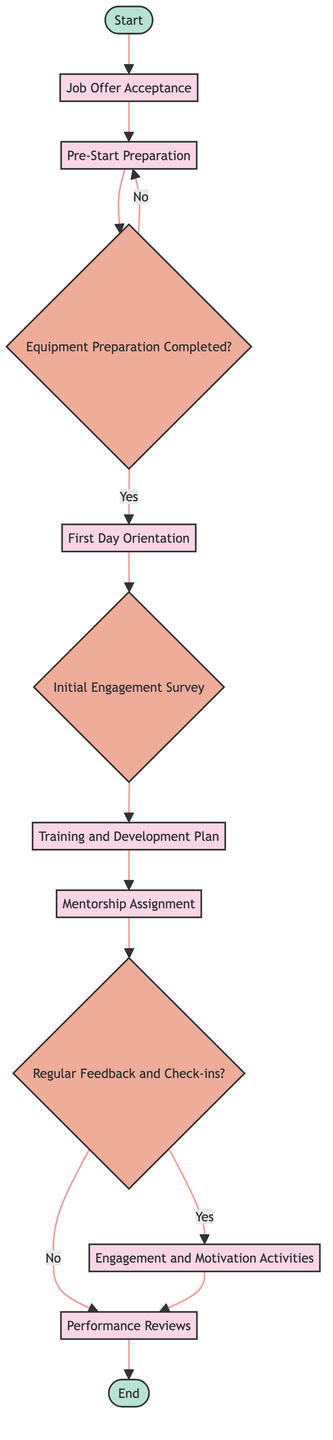What is the starting point of the onboarding process? The diagram begins at the "Start" node, indicating the entry point of the onboarding process.
Answer: Start How many decision nodes are there in the flowchart? The flowchart contains three decision nodes: "Equipment Preparation Completed?", "Initial Engagement Survey", and "Regular Feedback and Check-ins?".
Answer: 3 Which process comes after the "First Day Orientation"? Following the "First Day Orientation", the next action is to distribute the "Initial Engagement Survey".
Answer: Initial Engagement Survey What happens if "Equipment Preparation Completed?" is answered with "No"? If "Equipment Preparation Completed?" is answered with "No", the flowchart redirects back to "Pre-Start Preparation" for further action.
Answer: Pre-Start Preparation What is the end point of the onboarding process? The final point in the flowchart is the "End" node, which signifies the completion of the onboarding process.
Answer: End How many processes are in the onboarding flowchart? There are seven designated processes in the flowchart: "Job Offer Acceptance", "Pre-Start Preparation", "First Day Orientation", "Training and Development Plan", "Mentorship Assignment", "Engagement and Motivation Activities", and "Performance Reviews".
Answer: 7 What is the significance of the "Regular Feedback and Check-ins?" decision node? The "Regular Feedback and Check-ins?" node determines whether the onboarding process will include "Engagement and Motivation Activities" or go directly to "Performance Reviews", affecting the new hire's integration.
Answer: Engagement and Motivation Activities or Performance Reviews Which node follows the "Mentorship Assignment"? After "Mentorship Assignment," the next node in the process is "Regular Feedback and Check-ins?".
Answer: Regular Feedback and Check-ins? 